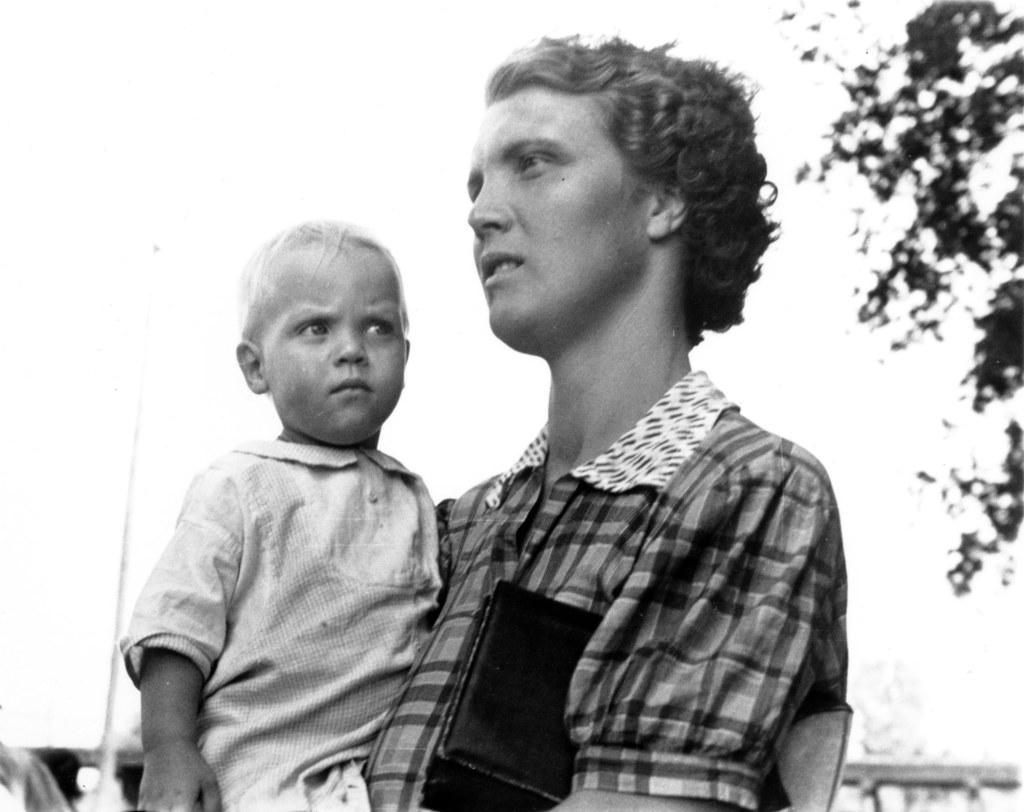Could you give a brief overview of what you see in this image? In the picture we can see a man holding a child and standing and in the background, we can see a pole, railing and a sky. 